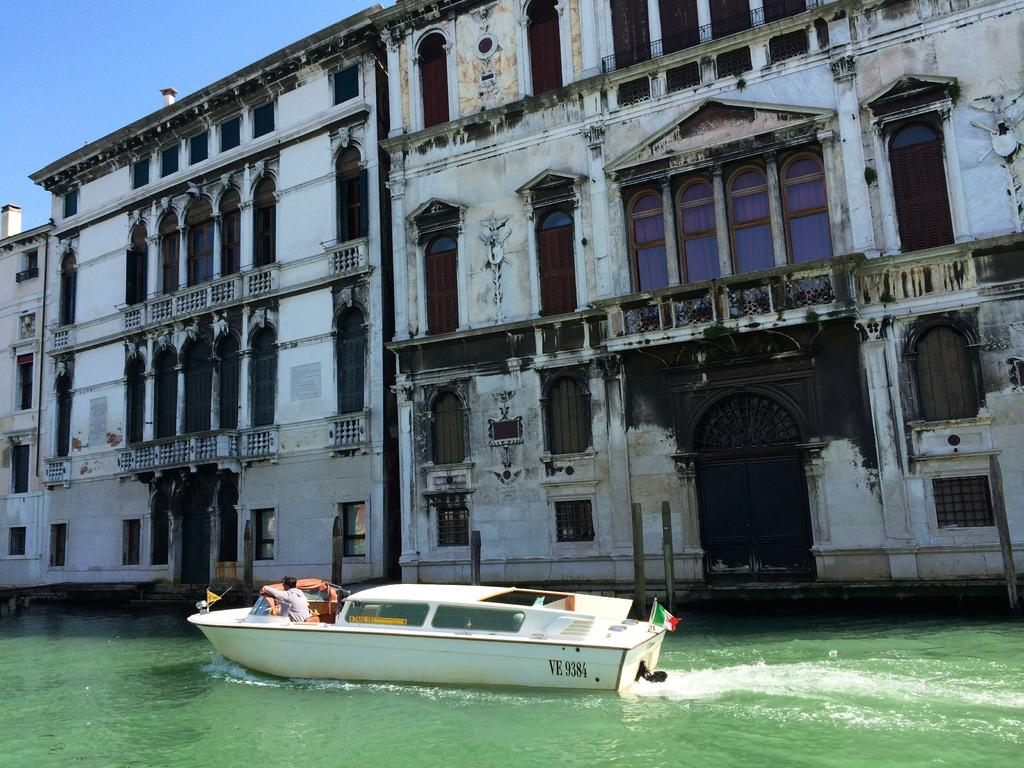<image>
Relay a brief, clear account of the picture shown. Boat that is riding on water next to a building with the number VE 9384. 